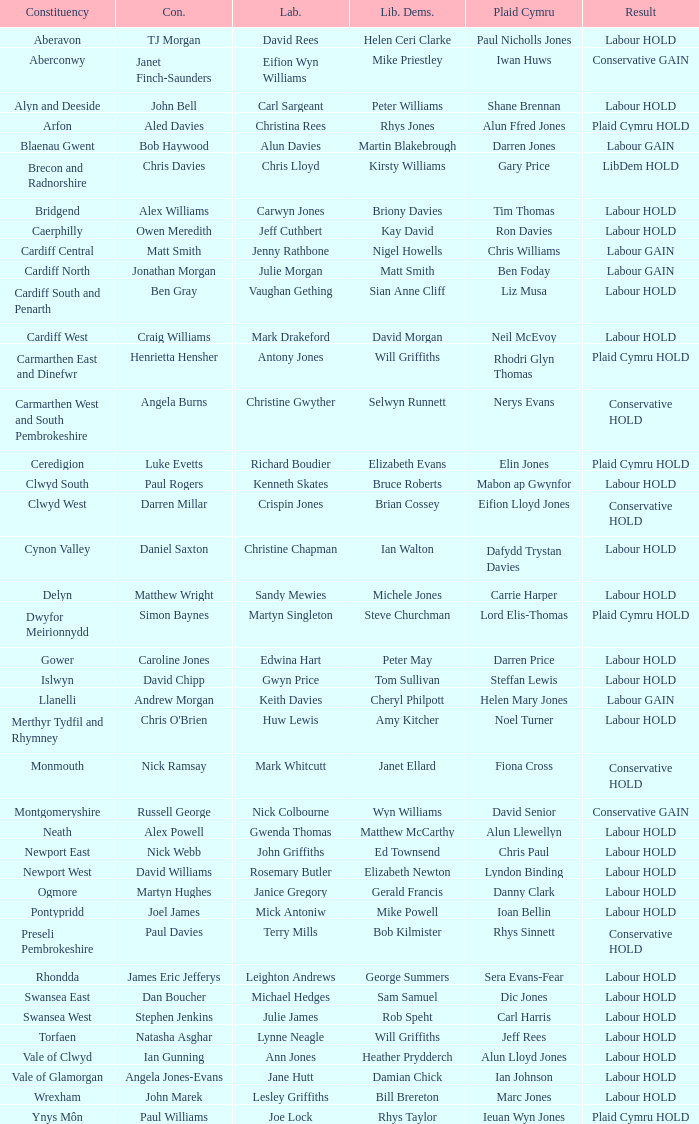What constituency does the Conservative Darren Millar belong to? Clwyd West. 